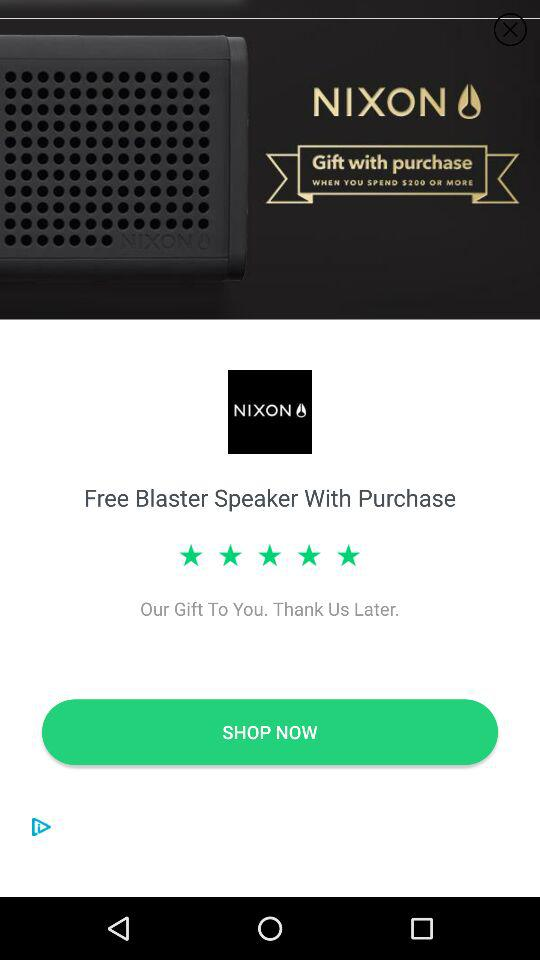How much more do I need to spend to get the free speaker?
Answer the question using a single word or phrase. $200 